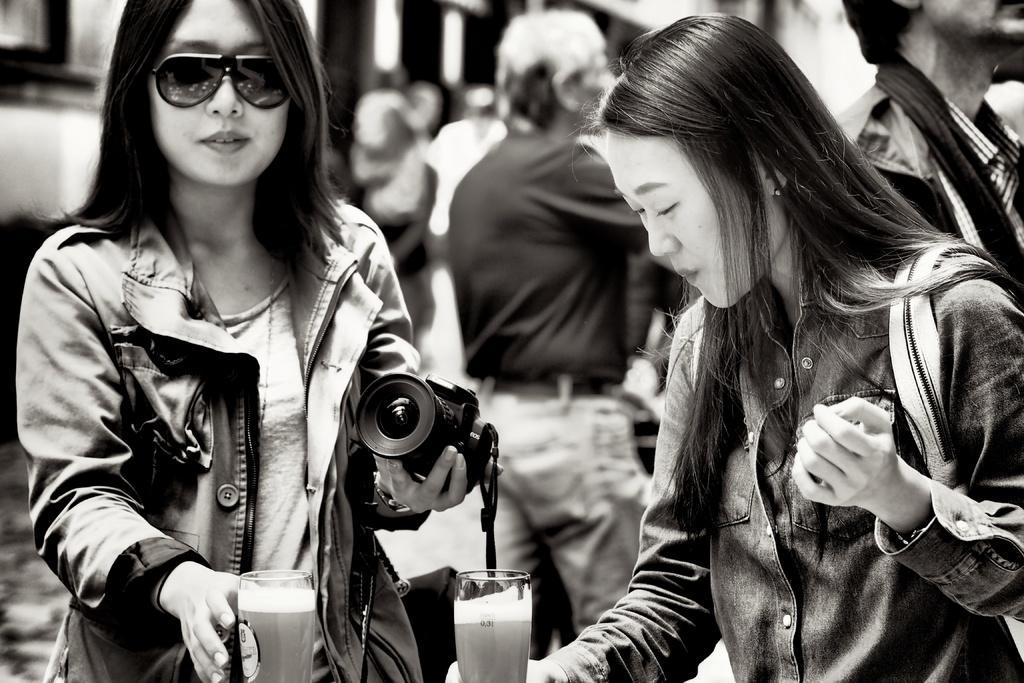Could you give a brief overview of what you see in this image? Two women are about to hold a glass. In them a woman is holding a camera in her hand. 